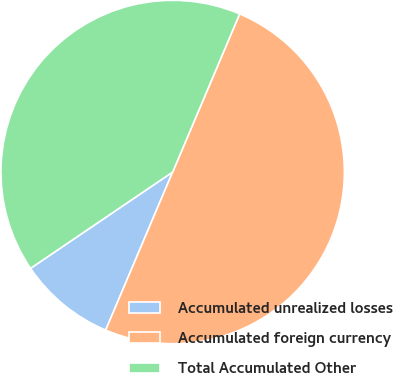<chart> <loc_0><loc_0><loc_500><loc_500><pie_chart><fcel>Accumulated unrealized losses<fcel>Accumulated foreign currency<fcel>Total Accumulated Other<nl><fcel>9.14%<fcel>50.0%<fcel>40.86%<nl></chart> 